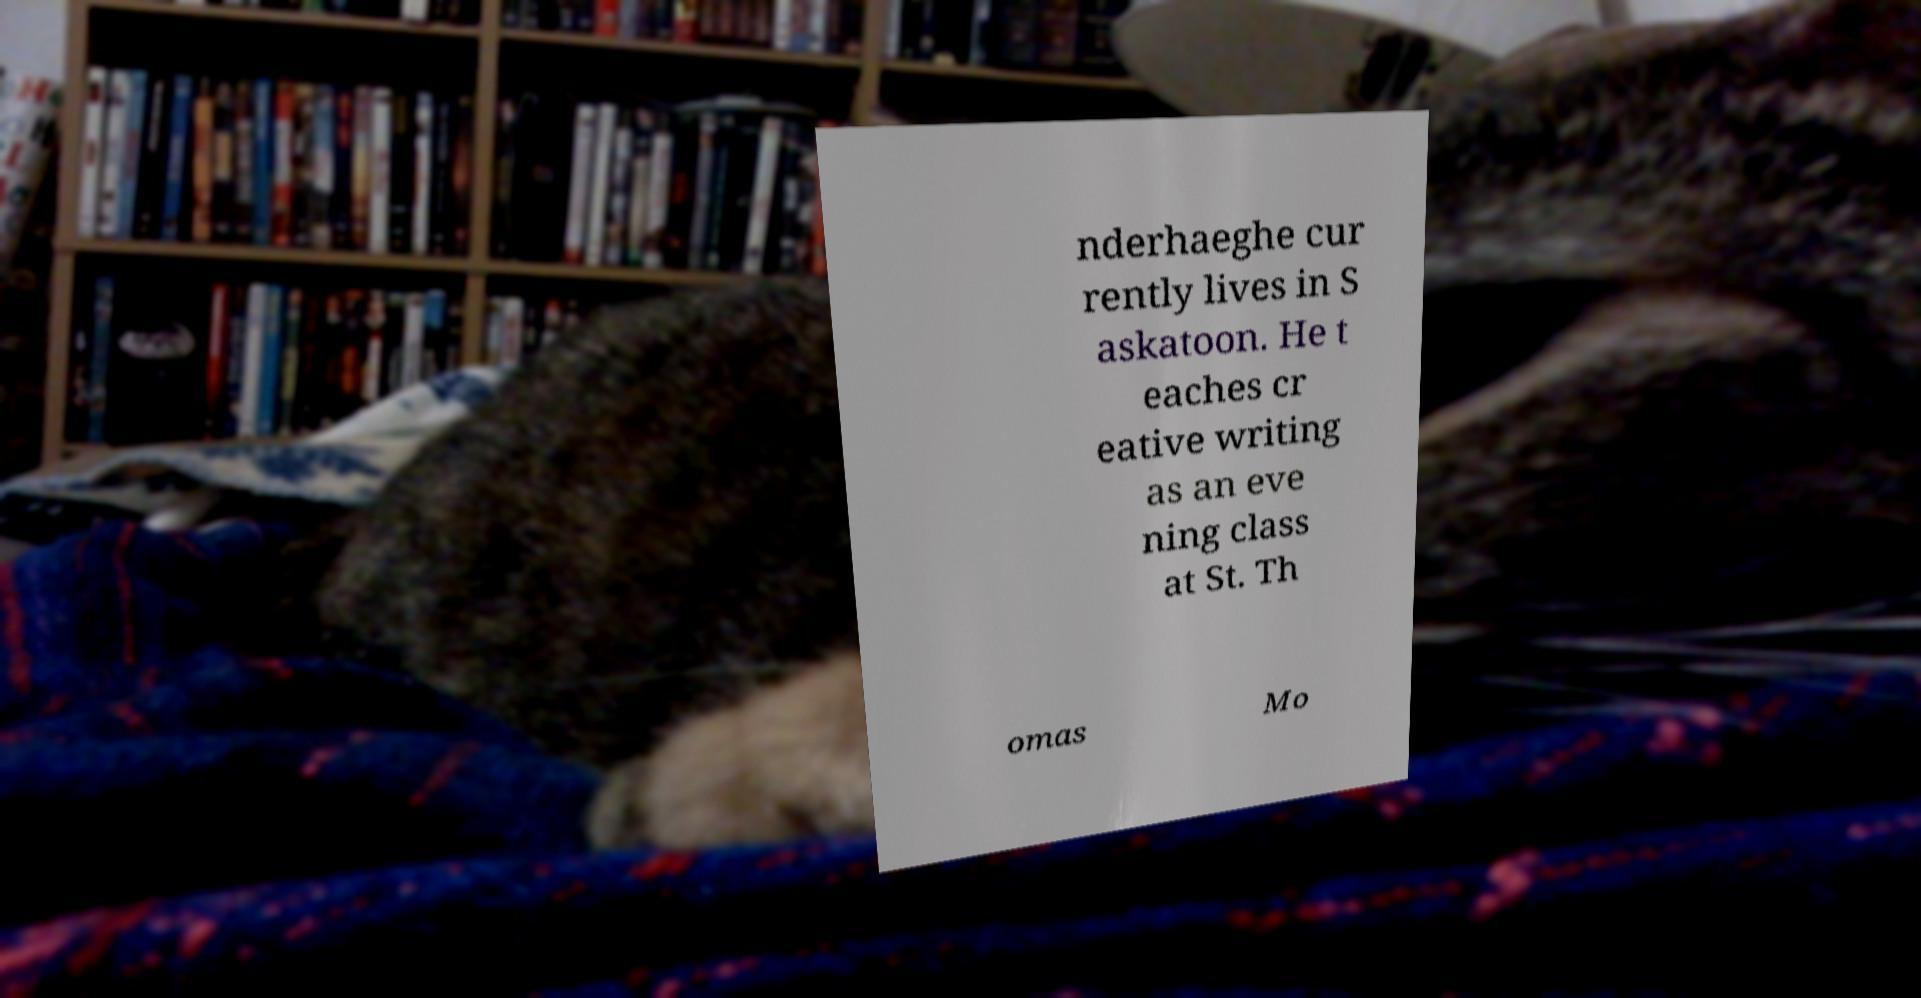For documentation purposes, I need the text within this image transcribed. Could you provide that? nderhaeghe cur rently lives in S askatoon. He t eaches cr eative writing as an eve ning class at St. Th omas Mo 